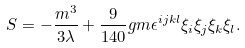<formula> <loc_0><loc_0><loc_500><loc_500>S = - \frac { m ^ { 3 } } { 3 \lambda } + \frac { 9 } { 1 4 0 } g m \epsilon ^ { i j k l } \xi _ { i } \xi _ { j } \xi _ { k } \xi _ { l } .</formula> 